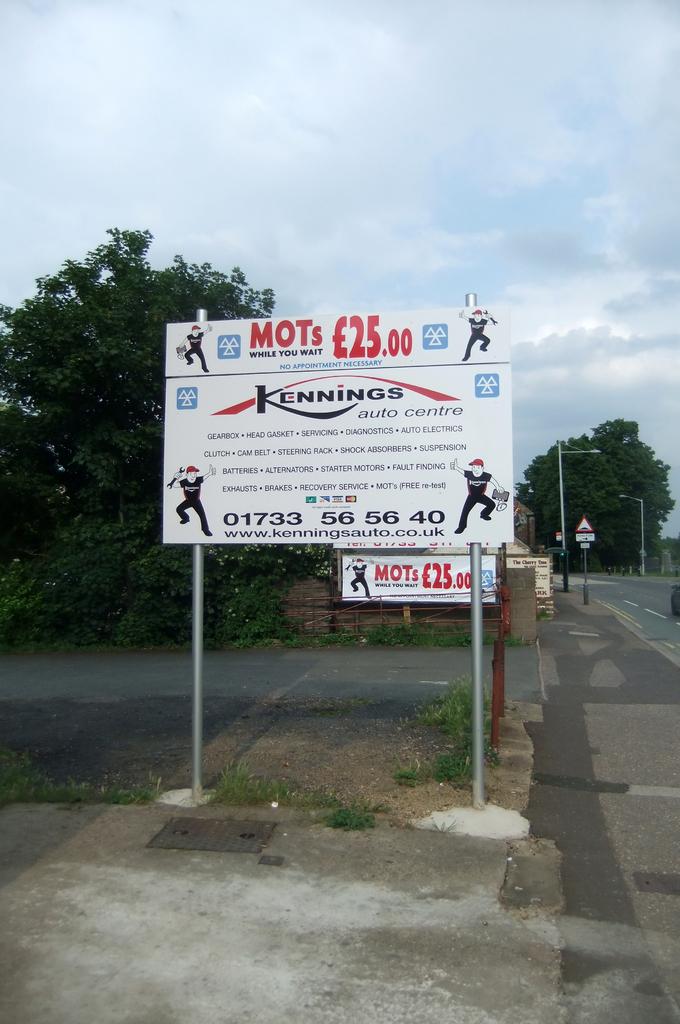What is being advertised?
Make the answer very short. Kennings auto centre. 